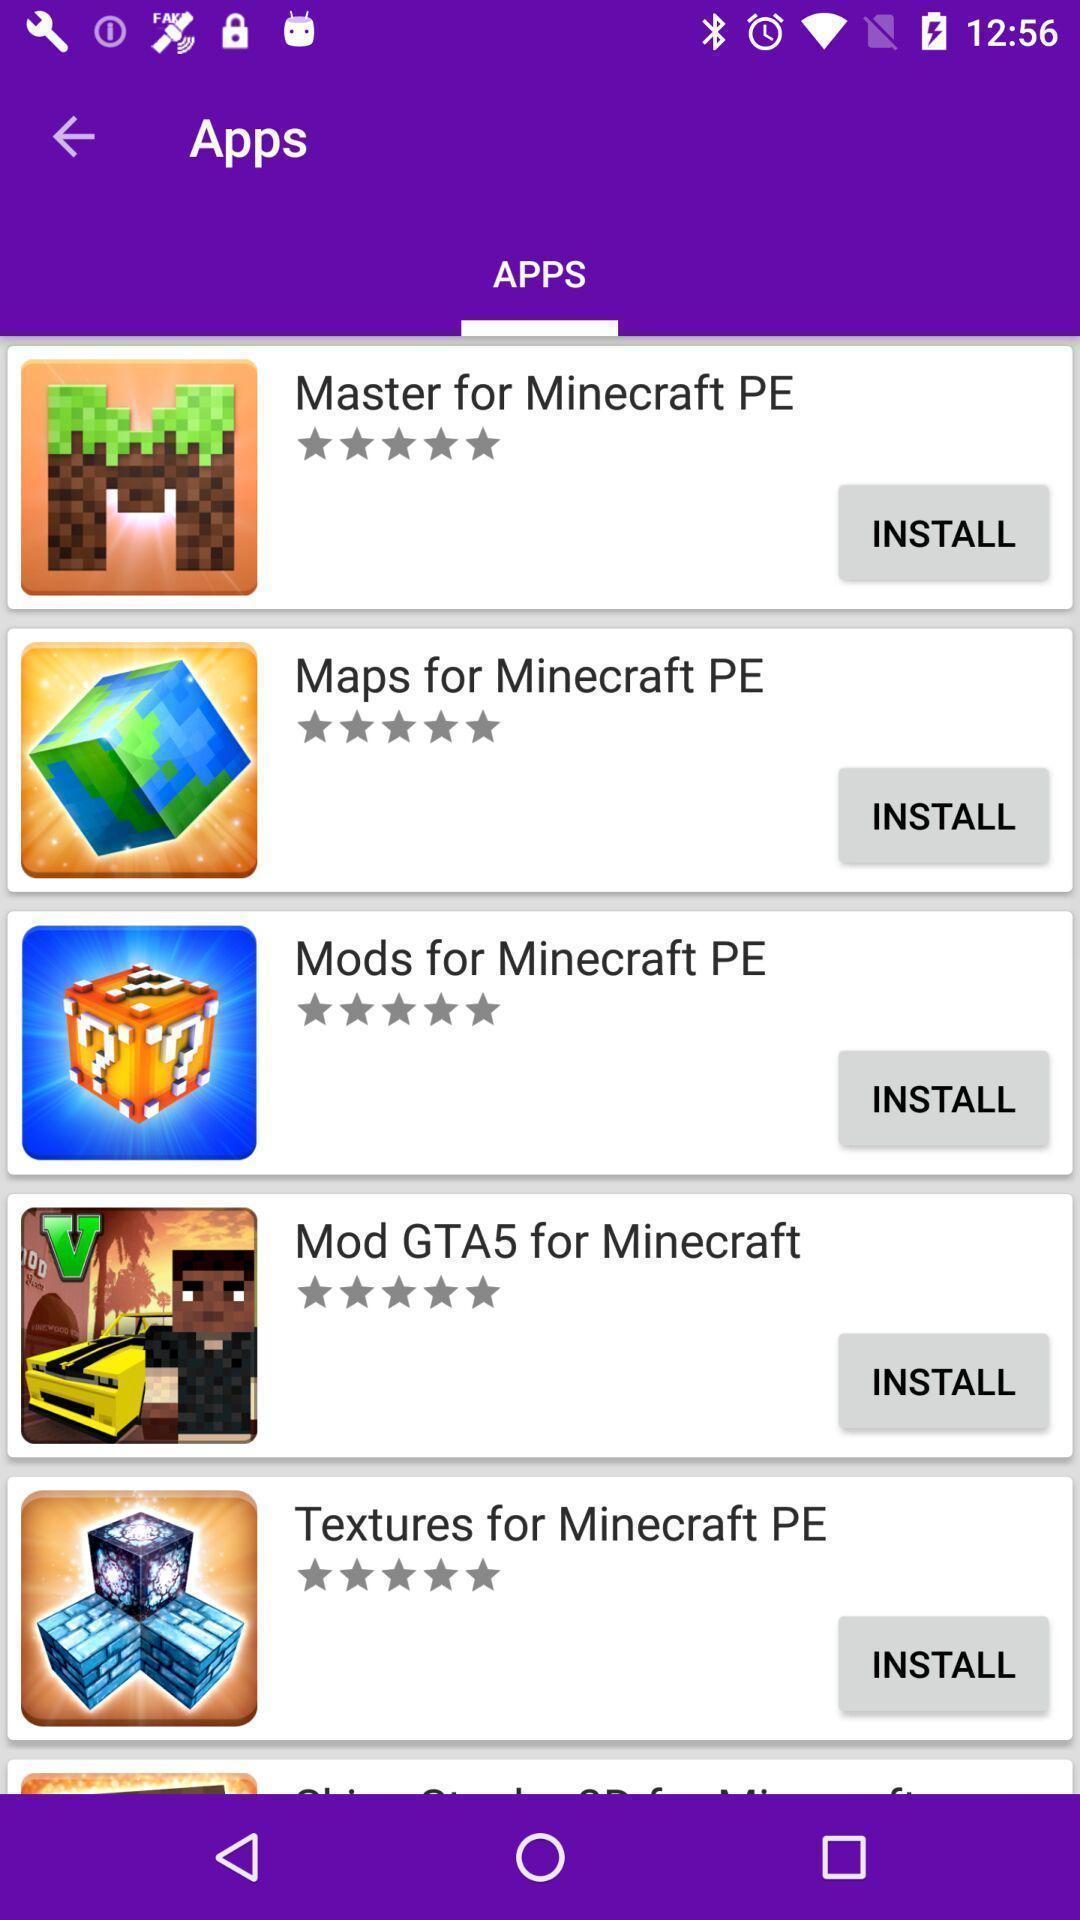What details can you identify in this image? Page shows list of apps to install. 